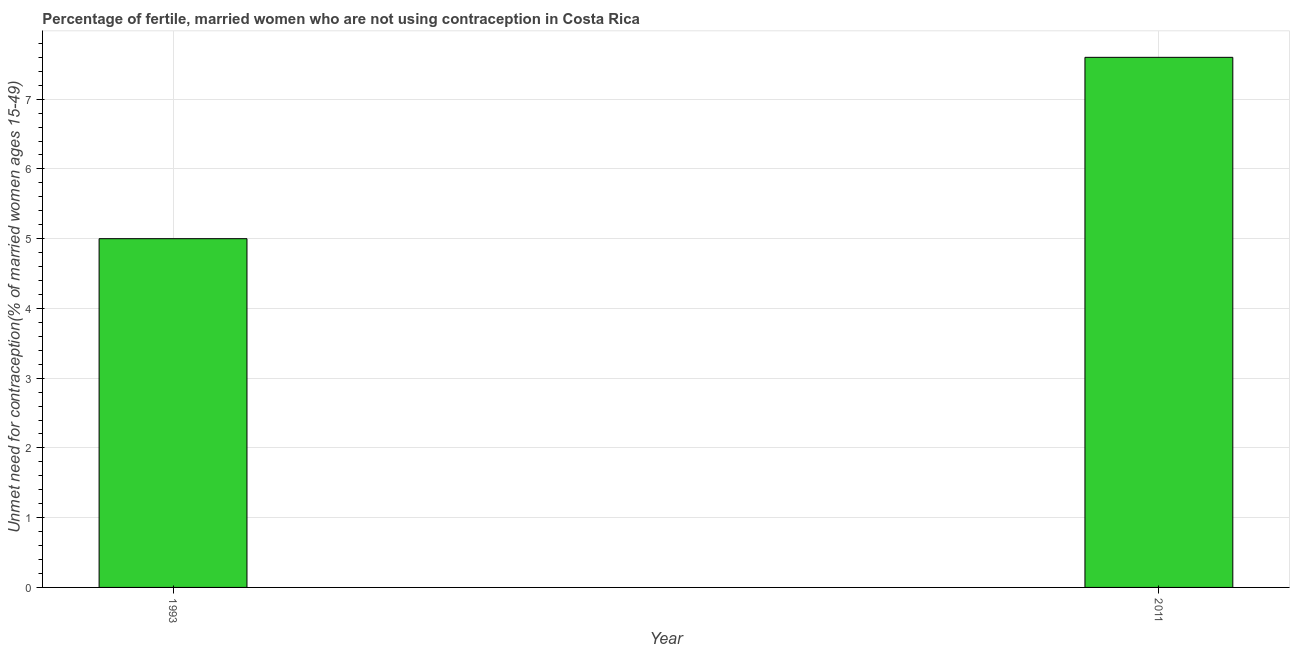Does the graph contain grids?
Provide a short and direct response. Yes. What is the title of the graph?
Provide a succinct answer. Percentage of fertile, married women who are not using contraception in Costa Rica. What is the label or title of the Y-axis?
Make the answer very short.  Unmet need for contraception(% of married women ages 15-49). What is the number of married women who are not using contraception in 2011?
Offer a very short reply. 7.6. In which year was the number of married women who are not using contraception maximum?
Ensure brevity in your answer.  2011. What is the sum of the number of married women who are not using contraception?
Provide a succinct answer. 12.6. What is the difference between the number of married women who are not using contraception in 1993 and 2011?
Offer a very short reply. -2.6. What is the average number of married women who are not using contraception per year?
Your answer should be compact. 6.3. What is the median number of married women who are not using contraception?
Your answer should be compact. 6.3. In how many years, is the number of married women who are not using contraception greater than 2.6 %?
Offer a terse response. 2. What is the ratio of the number of married women who are not using contraception in 1993 to that in 2011?
Offer a very short reply. 0.66. How many bars are there?
Offer a terse response. 2. Are all the bars in the graph horizontal?
Keep it short and to the point. No. How many years are there in the graph?
Offer a very short reply. 2. Are the values on the major ticks of Y-axis written in scientific E-notation?
Provide a succinct answer. No. What is the  Unmet need for contraception(% of married women ages 15-49) in 1993?
Provide a short and direct response. 5. What is the difference between the  Unmet need for contraception(% of married women ages 15-49) in 1993 and 2011?
Give a very brief answer. -2.6. What is the ratio of the  Unmet need for contraception(% of married women ages 15-49) in 1993 to that in 2011?
Ensure brevity in your answer.  0.66. 